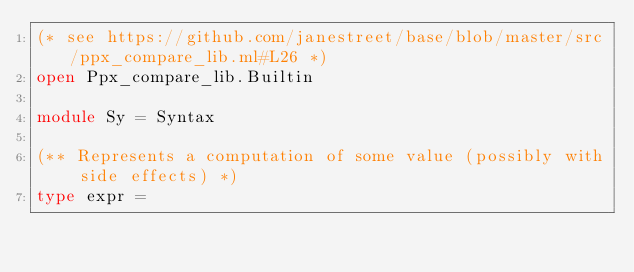Convert code to text. <code><loc_0><loc_0><loc_500><loc_500><_OCaml_>(* see https://github.com/janestreet/base/blob/master/src/ppx_compare_lib.ml#L26 *)
open Ppx_compare_lib.Builtin

module Sy = Syntax

(** Represents a computation of some value (possibly with side effects) *)
type expr =</code> 